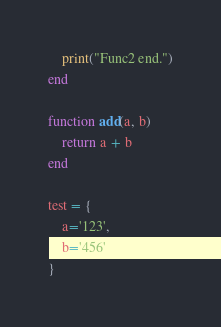<code> <loc_0><loc_0><loc_500><loc_500><_Lua_>    print("Func2 end.")
end

function add(a, b)
    return a + b
end

test = {
    a='123',
    b='456'
}
</code> 